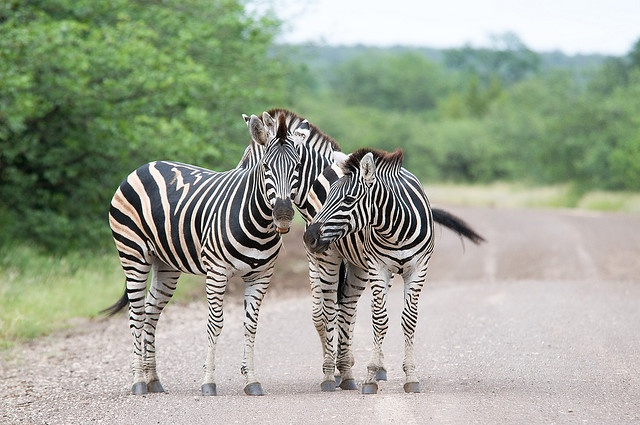Describe the objects in this image and their specific colors. I can see zebra in olive, lightgray, black, gray, and darkgray tones, zebra in olive, lightgray, black, darkgray, and gray tones, and zebra in olive, white, black, gray, and darkgray tones in this image. 